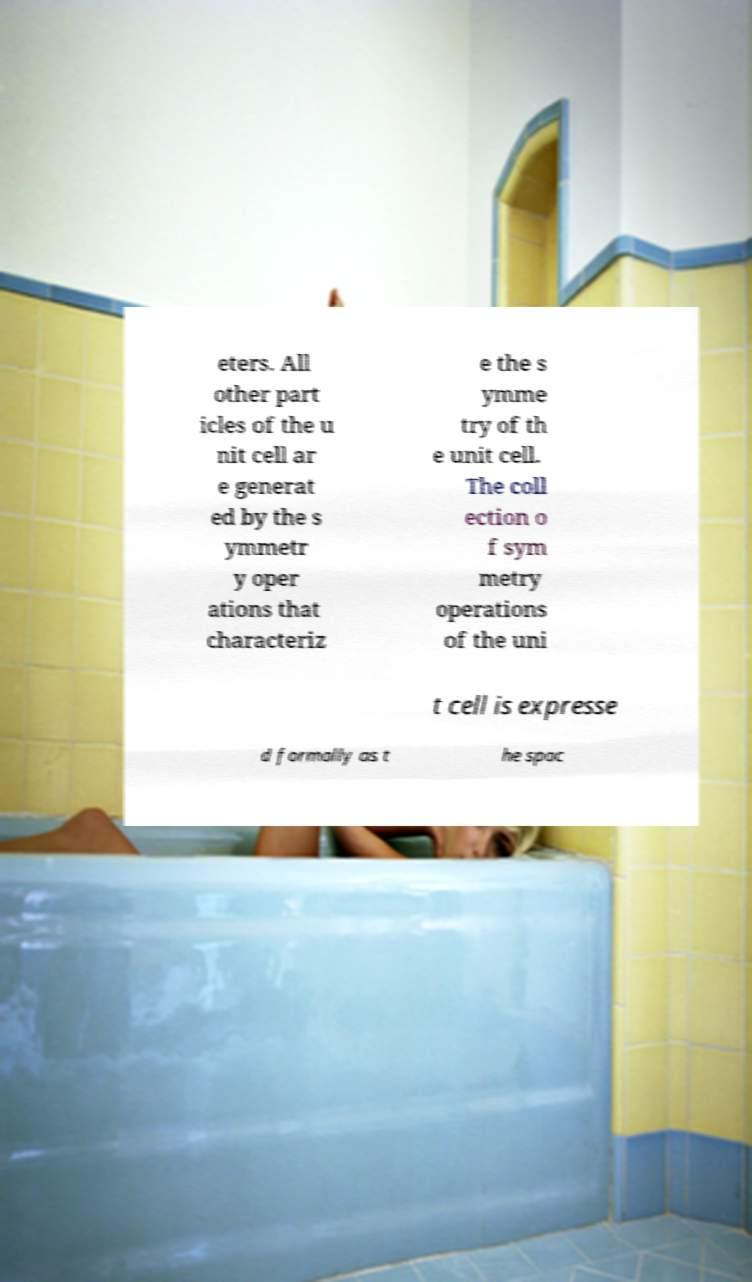There's text embedded in this image that I need extracted. Can you transcribe it verbatim? eters. All other part icles of the u nit cell ar e generat ed by the s ymmetr y oper ations that characteriz e the s ymme try of th e unit cell. The coll ection o f sym metry operations of the uni t cell is expresse d formally as t he spac 